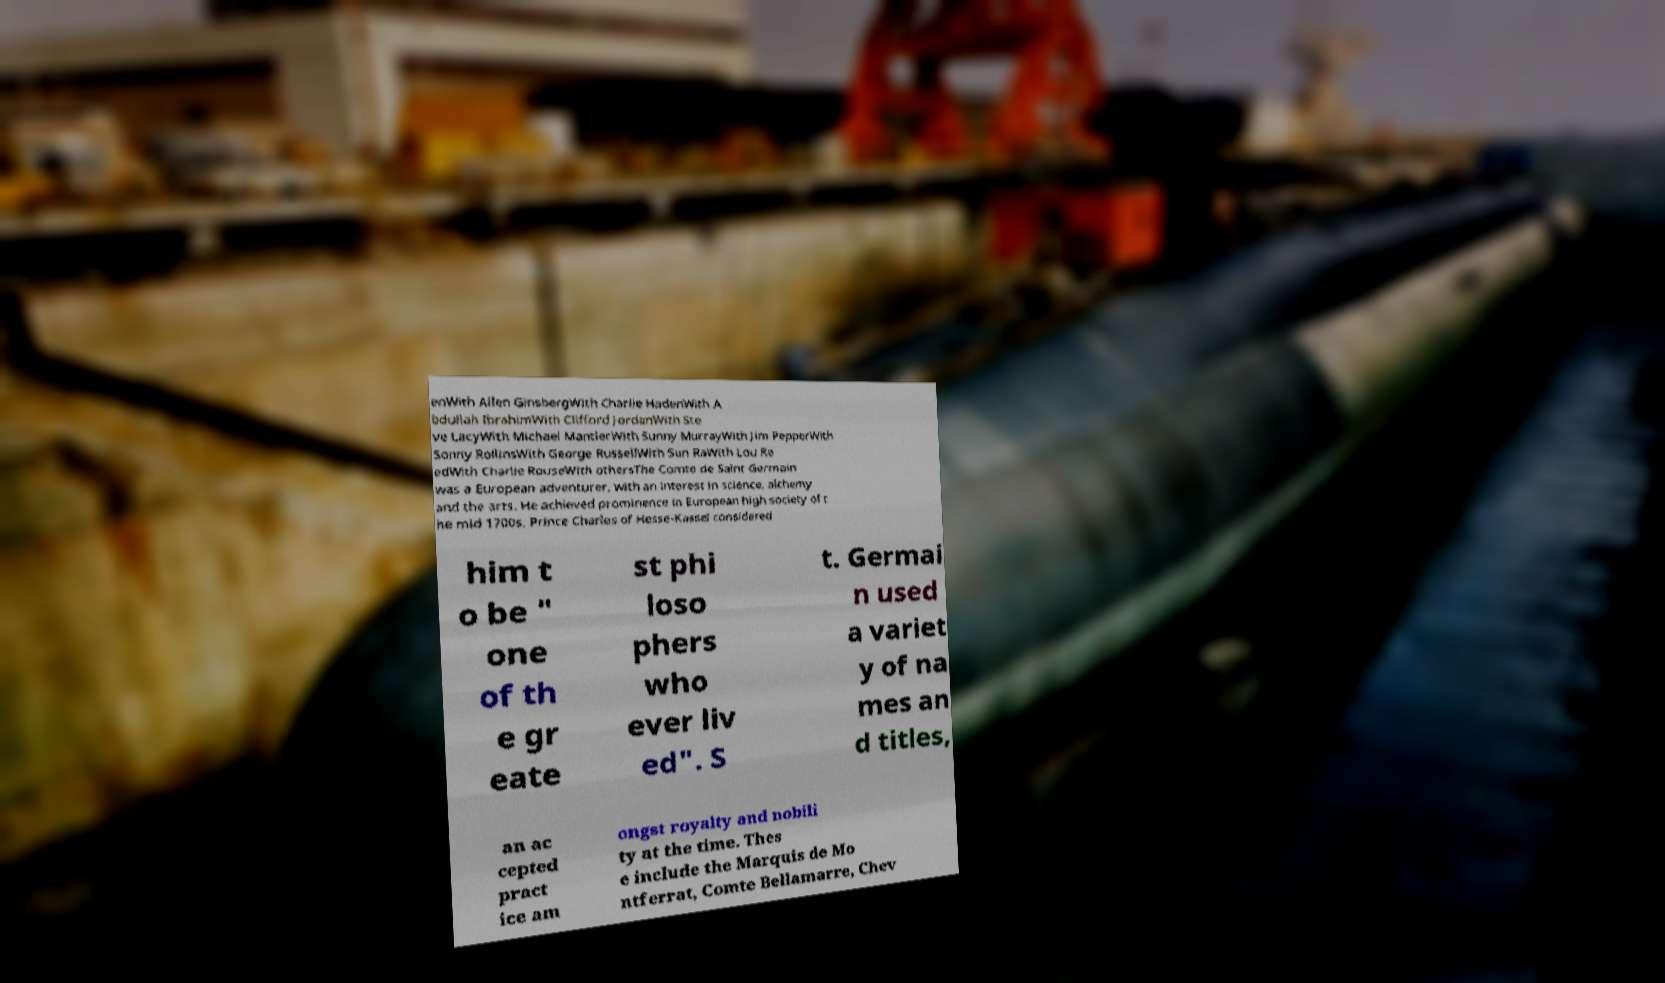Please read and relay the text visible in this image. What does it say? enWith Allen GinsbergWith Charlie HadenWith A bdullah IbrahimWith Clifford JordanWith Ste ve LacyWith Michael MantlerWith Sunny MurrayWith Jim PepperWith Sonny RollinsWith George RussellWith Sun RaWith Lou Re edWith Charlie RouseWith othersThe Comte de Saint Germain was a European adventurer, with an interest in science, alchemy and the arts. He achieved prominence in European high society of t he mid 1700s. Prince Charles of Hesse-Kassel considered him t o be " one of th e gr eate st phi loso phers who ever liv ed". S t. Germai n used a variet y of na mes an d titles, an ac cepted pract ice am ongst royalty and nobili ty at the time. Thes e include the Marquis de Mo ntferrat, Comte Bellamarre, Chev 